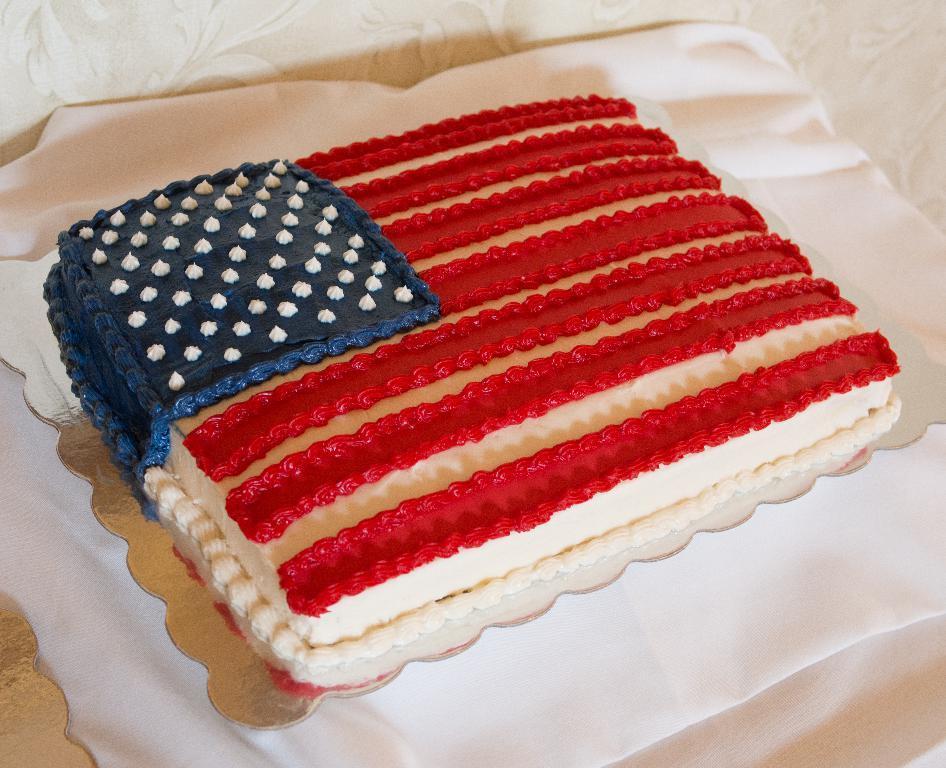Could you give a brief overview of what you see in this image? In the center of the image we can see a cake. At the bottom there is a white cloth. 